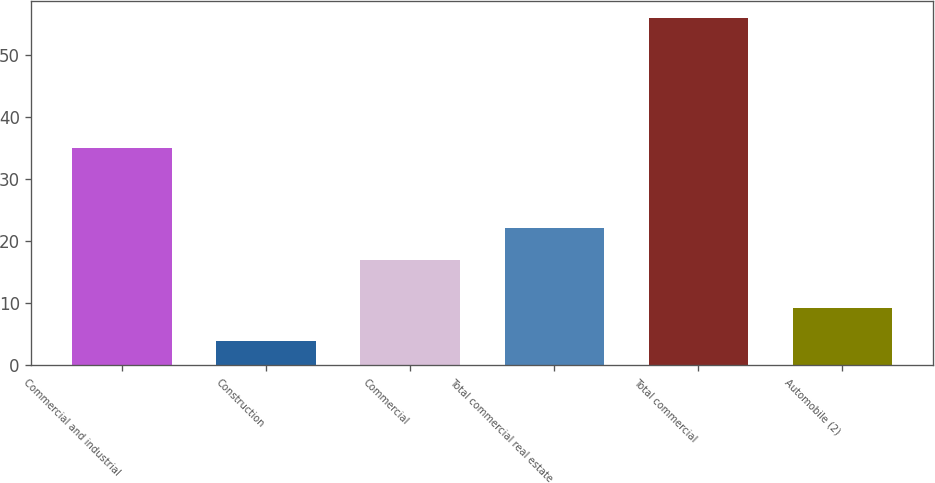Convert chart. <chart><loc_0><loc_0><loc_500><loc_500><bar_chart><fcel>Commercial and industrial<fcel>Construction<fcel>Commercial<fcel>Total commercial real estate<fcel>Total commercial<fcel>Automobile (2)<nl><fcel>35<fcel>4<fcel>17<fcel>22.2<fcel>56<fcel>9.2<nl></chart> 